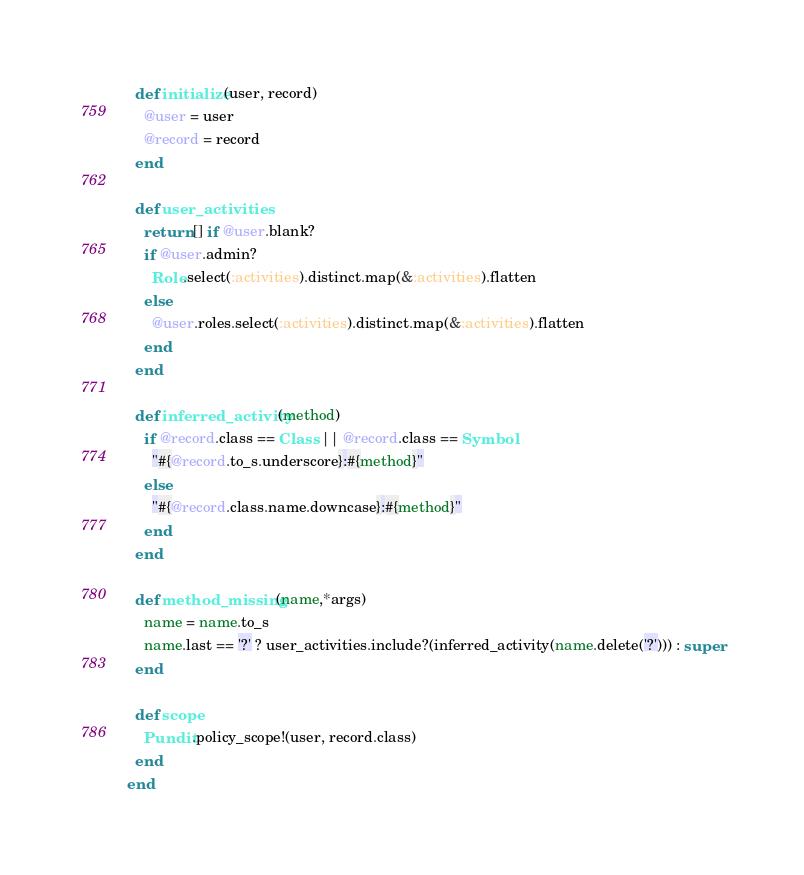<code> <loc_0><loc_0><loc_500><loc_500><_Ruby_>  def initialize(user, record)
    @user = user
    @record = record
  end

  def user_activities
    return [] if @user.blank?
    if @user.admin?
      Role.select(:activities).distinct.map(&:activities).flatten
    else
      @user.roles.select(:activities).distinct.map(&:activities).flatten
    end
  end

  def inferred_activity(method)
    if @record.class == Class || @record.class == Symbol
      "#{@record.to_s.underscore}:#{method}"
    else
      "#{@record.class.name.downcase}:#{method}"
    end
  end

  def method_missing(name,*args)
    name = name.to_s
    name.last == '?' ? user_activities.include?(inferred_activity(name.delete('?'))) : super
  end

  def scope
    Pundit.policy_scope!(user, record.class)
  end
end
</code> 